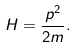<formula> <loc_0><loc_0><loc_500><loc_500>H = \frac { p ^ { 2 } } { 2 m } .</formula> 